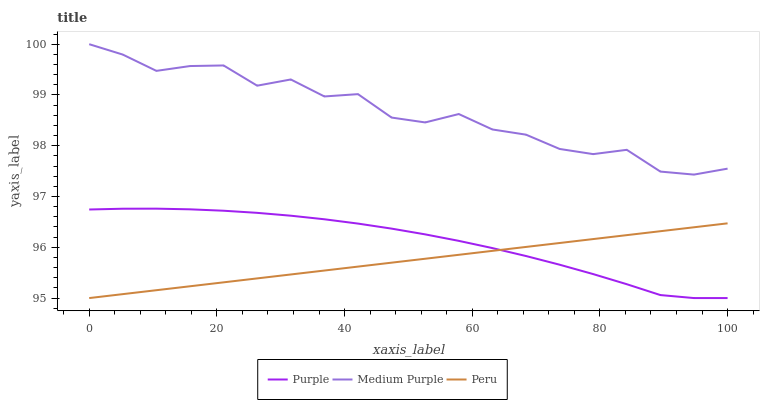Does Medium Purple have the minimum area under the curve?
Answer yes or no. No. Does Peru have the maximum area under the curve?
Answer yes or no. No. Is Medium Purple the smoothest?
Answer yes or no. No. Is Peru the roughest?
Answer yes or no. No. Does Medium Purple have the lowest value?
Answer yes or no. No. Does Peru have the highest value?
Answer yes or no. No. Is Purple less than Medium Purple?
Answer yes or no. Yes. Is Medium Purple greater than Peru?
Answer yes or no. Yes. Does Purple intersect Medium Purple?
Answer yes or no. No. 